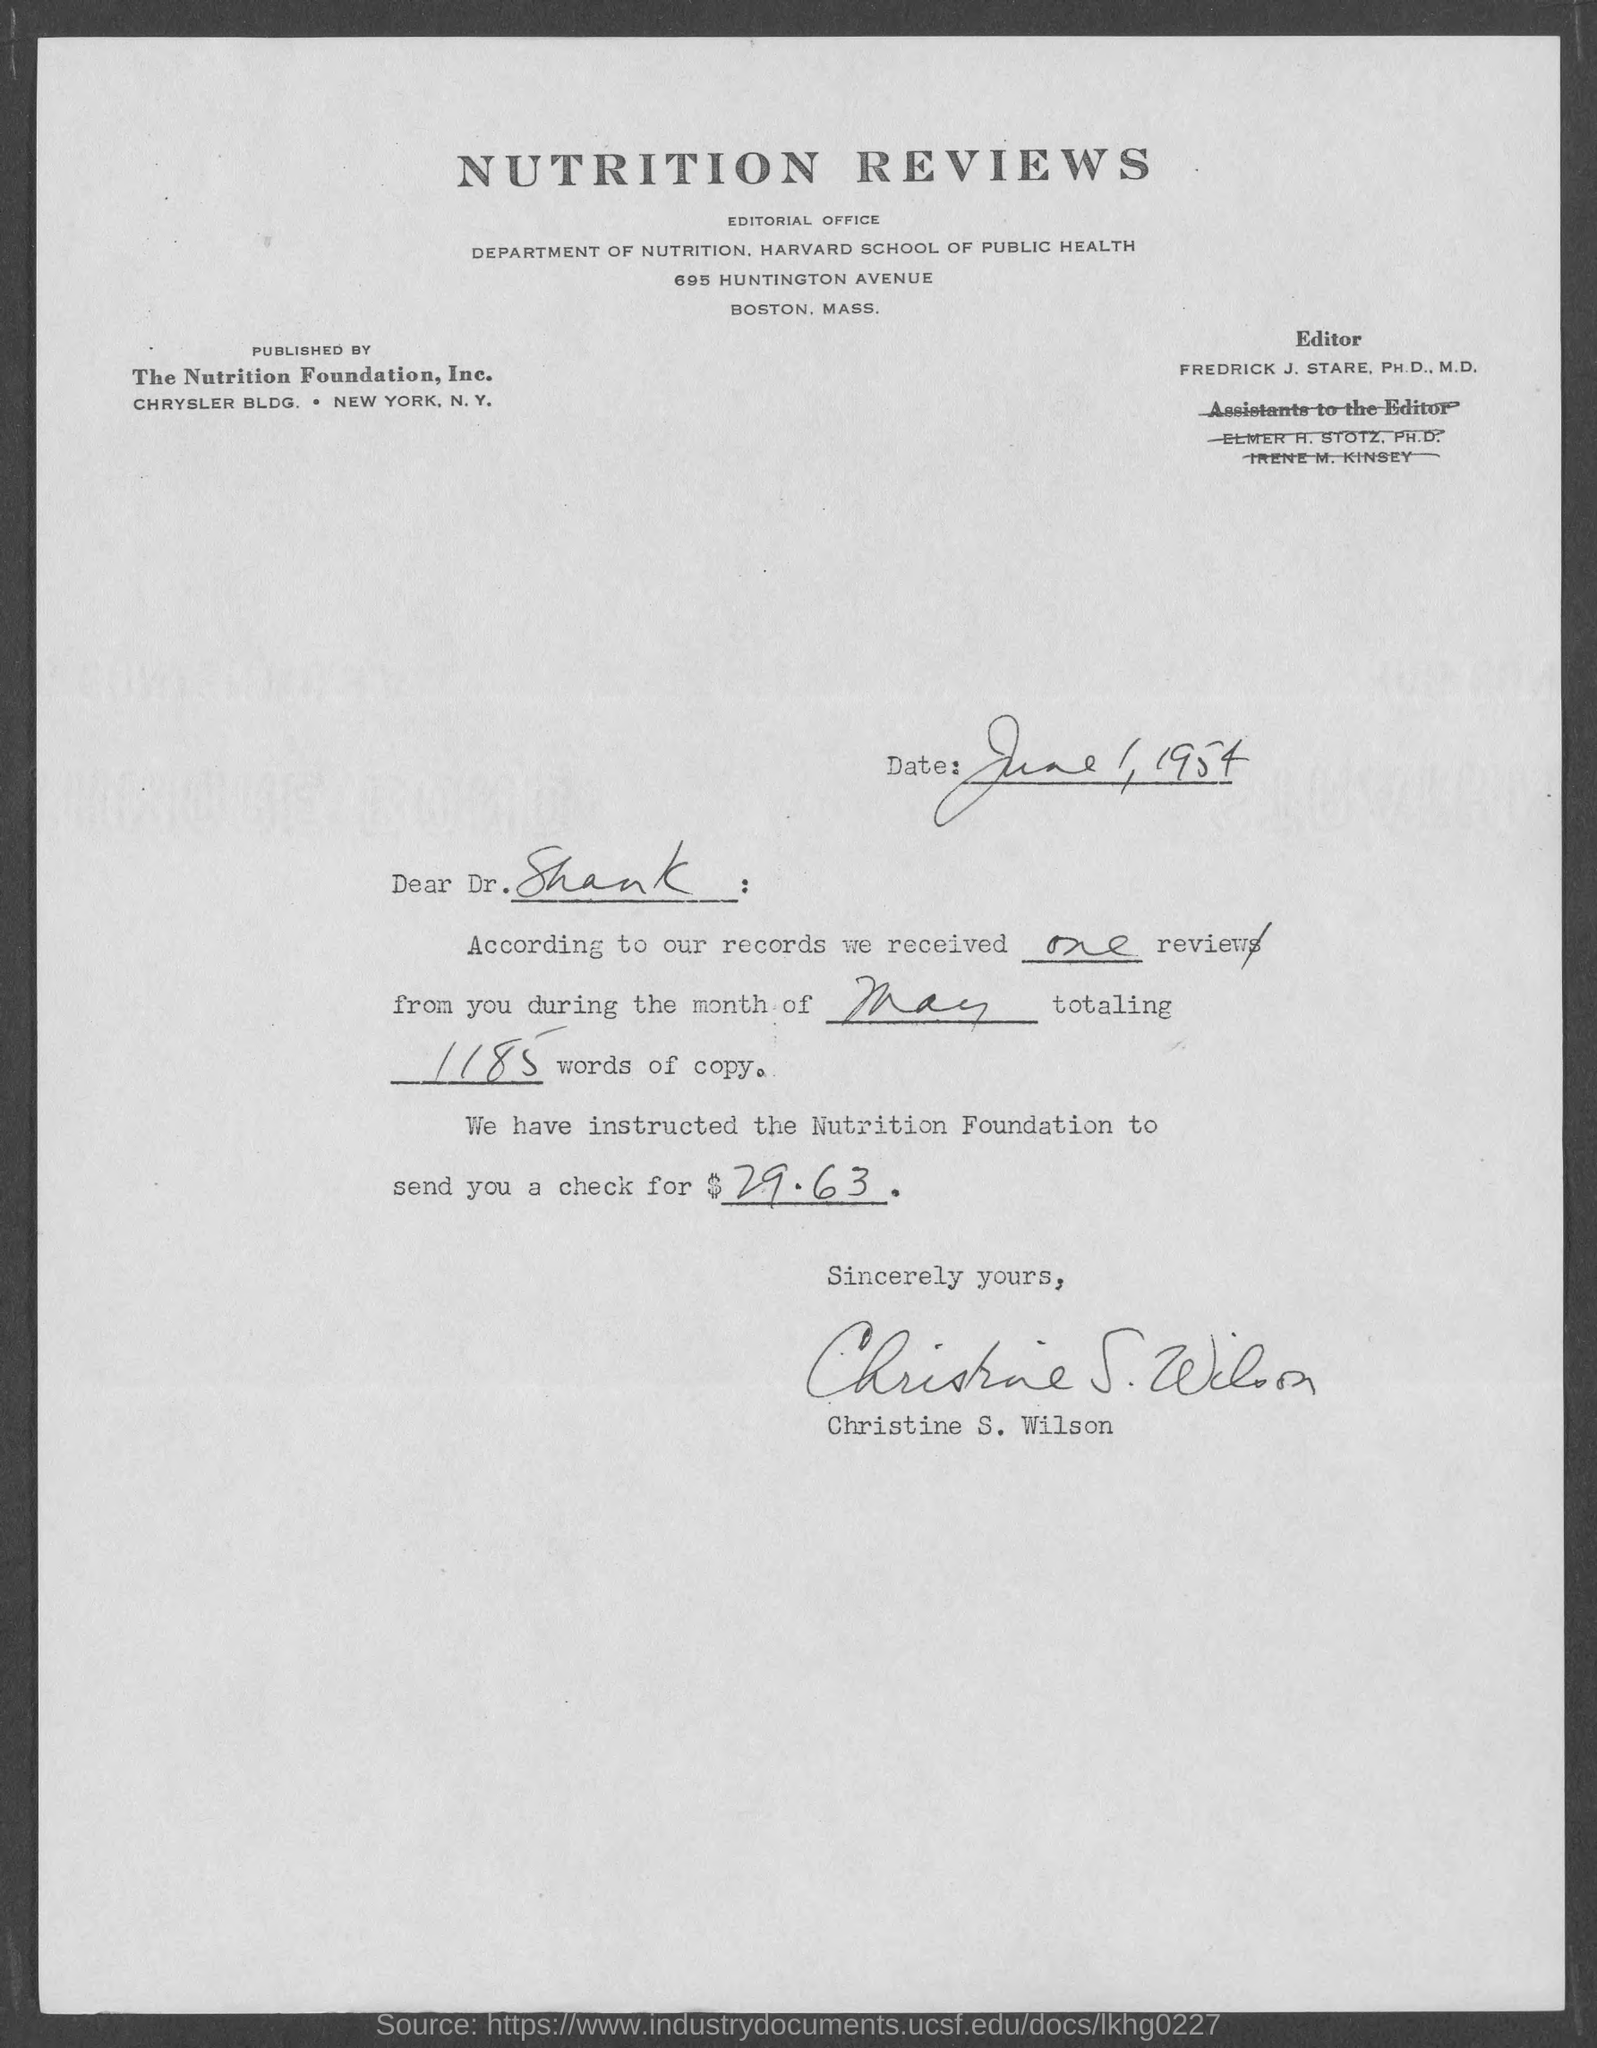Mention a couple of crucial points in this snapshot. The Nutrition Foundation was the publisher of this letter. The editor mentioned in the given page is Fredrick J. Stare. According to our records, only one review was received. The Department of Nutrition at the Harvard School of Public Health is mentioned in the given page. The reviews were received during the month mentioned in the given letter, which is May. 